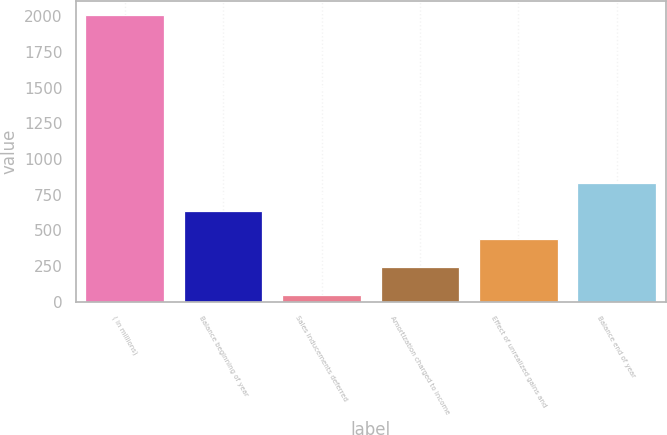<chart> <loc_0><loc_0><loc_500><loc_500><bar_chart><fcel>( in millions)<fcel>Balance beginning of year<fcel>Sales inducements deferred<fcel>Amortization charged to income<fcel>Effect of unrealized gains and<fcel>Balance end of year<nl><fcel>2008<fcel>635.3<fcel>47<fcel>243.1<fcel>439.2<fcel>831.4<nl></chart> 